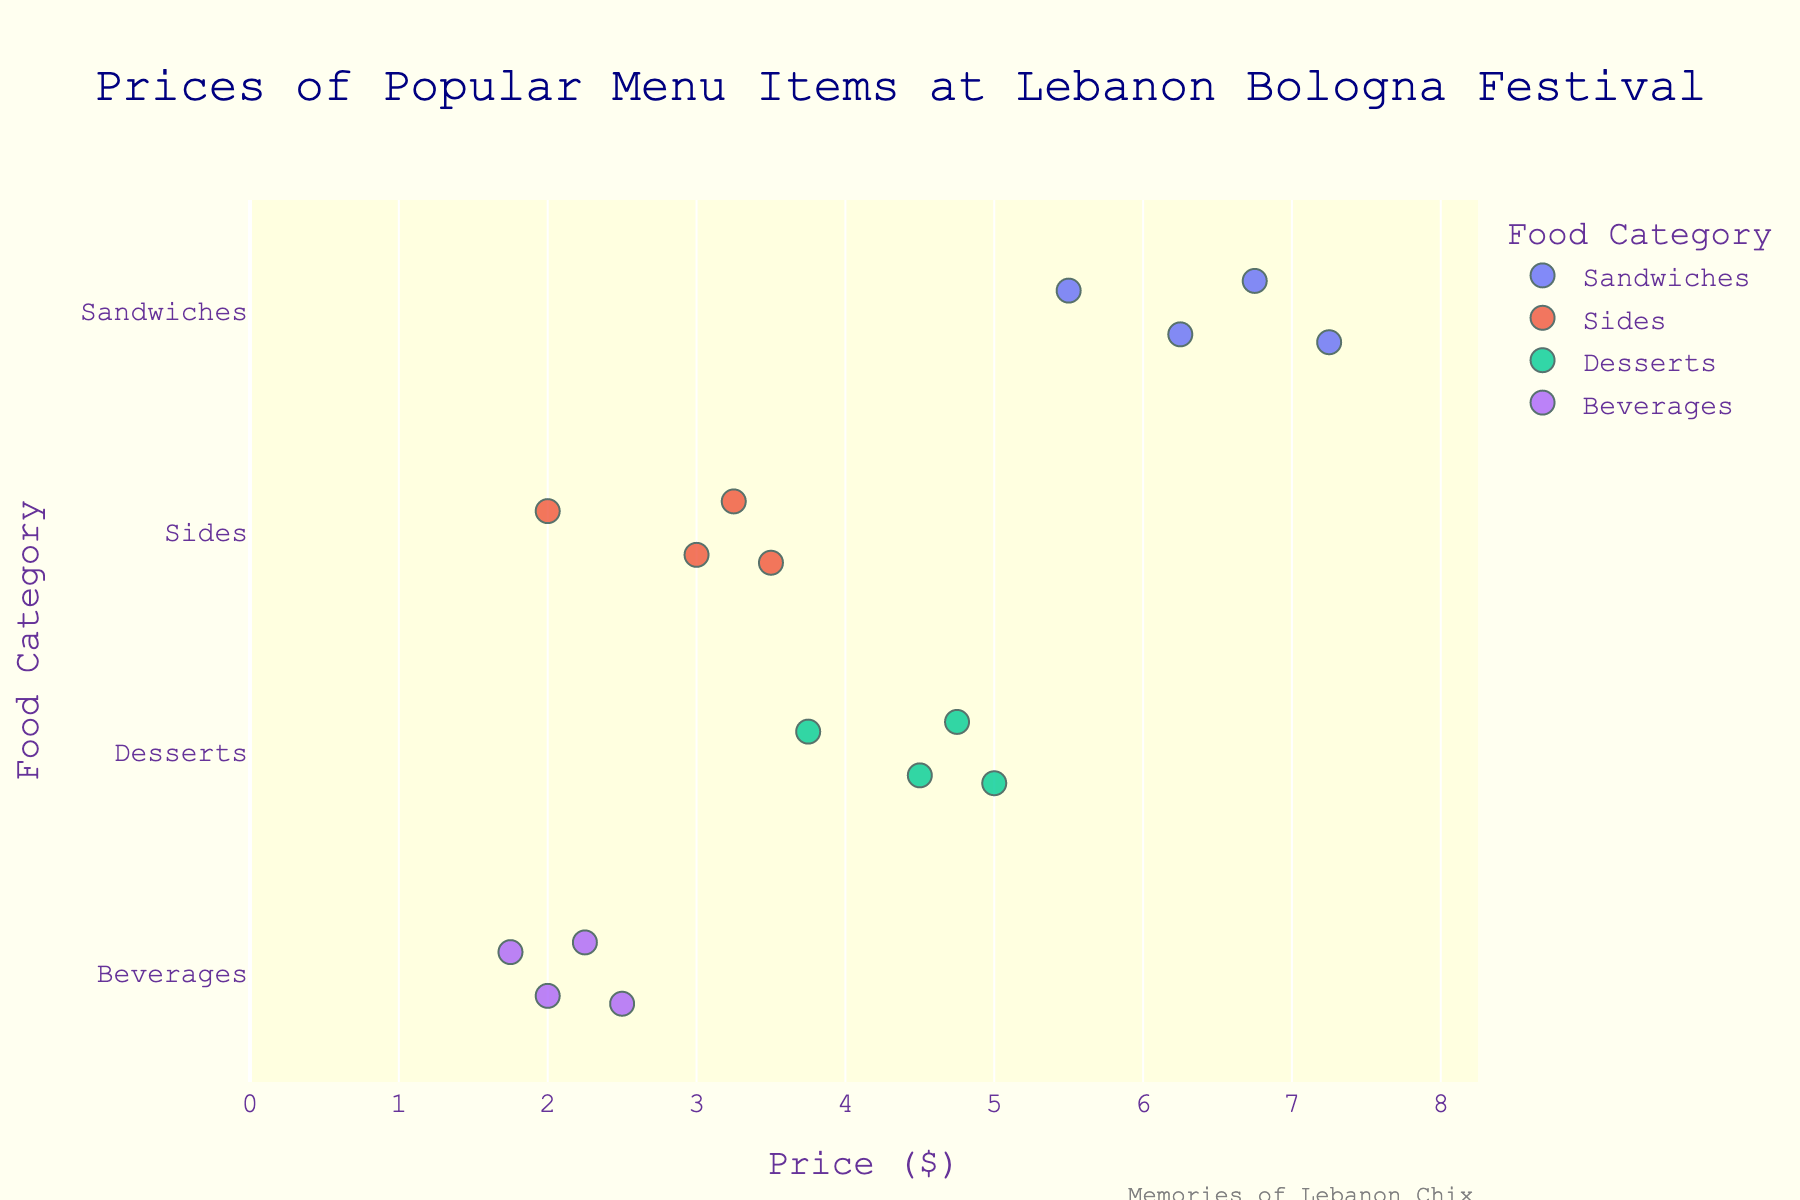What's the title of the plot? The title is usually located at the top of the plot. In this case, it reads "Prices of Popular Menu Items at Lebanon Bologna Festival."
Answer: Prices of Popular Menu Items at Lebanon Bologna Festival What are the food categories displayed on the y-axis? The y-axis lists the food categories. Here, the categories are Sandwiches, Sides, Desserts, and Beverages.
Answer: Sandwiches, Sides, Desserts, Beverages Which food category has the highest average price? To find the category with the highest average price, we need to calculate the average price for each category and then compare them. The average can be calculated as follows:
- Sandwiches: (5.50 + 6.75 + 7.25 + 6.25) / 4 = 6.44
- Sides: (3.50 + 3.00 + 3.25 + 2.00) / 4 = 2.94
- Desserts: (4.50 + 5.00 + 4.75 + 3.75) / 4 = 4.50
- Beverages: (2.50 + 2.25 + 1.75 + 2.00) / 4 = 2.13
The category with the highest average price is Sandwiches, with an average price of $6.44.
Answer: Sandwiches Which food item is the most expensive? By looking at the x-axis (Price) and checking the furthermost right data point, we can determine the most expensive item. The Fried Bologna Burger in the Sandwiches category is priced at $7.25, making it the most expensive item.
Answer: Fried Bologna Burger What is the price range of the Beverages category? To find the price range, we identify the lowest and highest prices in the Beverages category:
- Lowest: Coffee at $1.75
- Highest: Birch Beer at $2.50
The range is $2.50 - $1.75 = $0.75.
Answer: $0.75 How do the prices of the items in the Desserts category compare with those in the Sides category? We compare the prices in both categories directly:
- Desserts: $4.50, $5.00, $4.75, $3.75
- Sides: $3.50, $3.00, $3.25, $2.00
The prices in Desserts are higher overall compared to Sides.
Answer: Desserts are higher What is the median price of Sandwiches? To find the median, we sort the prices of Sandwiches in ascending order and find the middle value. Prices (sorted): $5.50, $6.25, $6.75, $7.25. The median is the average of the two middle values: ($6.25 + $6.75) / 2 = $6.50.
Answer: $6.50 How many items are priced below $4.00? To answer this, we count all the items that have prices less than $4. We identify the items: Coleslaw ($3.00), Macaroni Salad ($3.25), Pickles ($2.00), Lemonade ($2.25), Birch Beer ($2.50), Iced Tea ($2.00), Coffee ($1.75). There are 7 items.
Answer: 7 What is the cheapest item at the festival? By looking at the data points closest to the origin ($0.00), we can identify Coffee in the Beverages category as the cheapest item, priced at $1.75.
Answer: Coffee What is the average price of items in the Desserts category? To find the average price:
- Add up the prices: $4.50 + $5.00 + $4.75 + $3.75 = $18.00
- Divide by the number of items: $18.00 / 4 = $4.50
The average price of items in Desserts is $4.50.
Answer: $4.50 